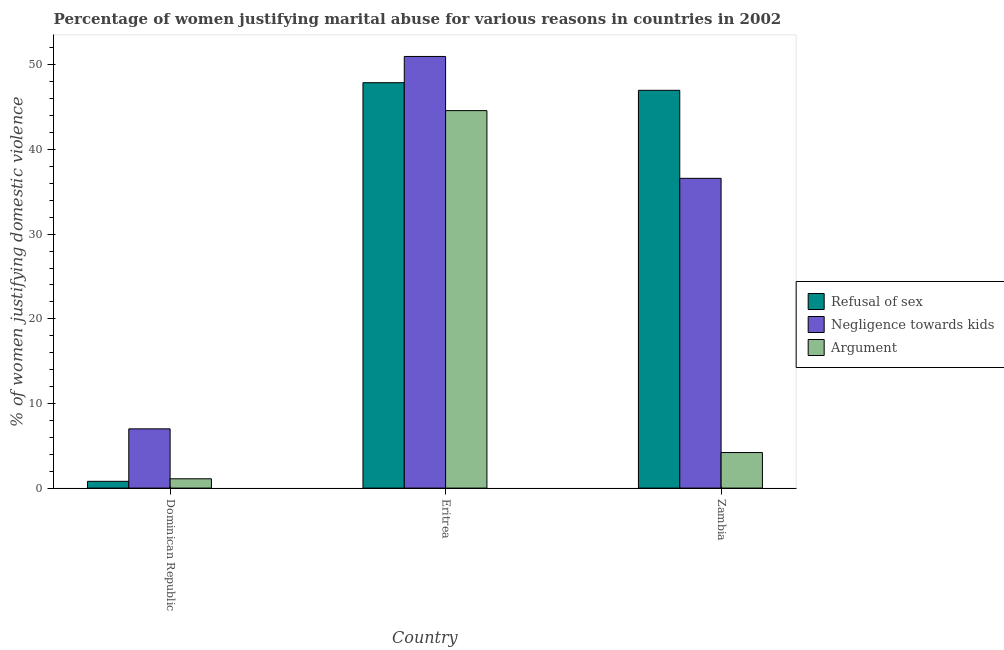How many different coloured bars are there?
Your answer should be compact. 3. Are the number of bars on each tick of the X-axis equal?
Keep it short and to the point. Yes. How many bars are there on the 3rd tick from the left?
Keep it short and to the point. 3. What is the label of the 1st group of bars from the left?
Offer a very short reply. Dominican Republic. What is the percentage of women justifying domestic violence due to negligence towards kids in Zambia?
Provide a succinct answer. 36.6. Across all countries, what is the minimum percentage of women justifying domestic violence due to negligence towards kids?
Your answer should be very brief. 7. In which country was the percentage of women justifying domestic violence due to arguments maximum?
Make the answer very short. Eritrea. In which country was the percentage of women justifying domestic violence due to negligence towards kids minimum?
Give a very brief answer. Dominican Republic. What is the total percentage of women justifying domestic violence due to arguments in the graph?
Ensure brevity in your answer.  49.9. What is the difference between the percentage of women justifying domestic violence due to negligence towards kids in Dominican Republic and that in Zambia?
Keep it short and to the point. -29.6. What is the difference between the percentage of women justifying domestic violence due to arguments in Dominican Republic and the percentage of women justifying domestic violence due to negligence towards kids in Eritrea?
Provide a succinct answer. -49.9. What is the average percentage of women justifying domestic violence due to negligence towards kids per country?
Ensure brevity in your answer.  31.53. In how many countries, is the percentage of women justifying domestic violence due to negligence towards kids greater than 4 %?
Your answer should be compact. 3. What is the ratio of the percentage of women justifying domestic violence due to negligence towards kids in Eritrea to that in Zambia?
Make the answer very short. 1.39. Is the percentage of women justifying domestic violence due to arguments in Eritrea less than that in Zambia?
Your answer should be compact. No. What is the difference between the highest and the second highest percentage of women justifying domestic violence due to refusal of sex?
Your response must be concise. 0.9. Is the sum of the percentage of women justifying domestic violence due to refusal of sex in Eritrea and Zambia greater than the maximum percentage of women justifying domestic violence due to arguments across all countries?
Offer a terse response. Yes. What does the 1st bar from the left in Zambia represents?
Offer a very short reply. Refusal of sex. What does the 2nd bar from the right in Zambia represents?
Keep it short and to the point. Negligence towards kids. How many countries are there in the graph?
Make the answer very short. 3. Does the graph contain grids?
Make the answer very short. No. Where does the legend appear in the graph?
Keep it short and to the point. Center right. How many legend labels are there?
Your answer should be compact. 3. What is the title of the graph?
Keep it short and to the point. Percentage of women justifying marital abuse for various reasons in countries in 2002. Does "Hydroelectric sources" appear as one of the legend labels in the graph?
Your answer should be compact. No. What is the label or title of the Y-axis?
Provide a succinct answer. % of women justifying domestic violence. What is the % of women justifying domestic violence of Refusal of sex in Dominican Republic?
Keep it short and to the point. 0.8. What is the % of women justifying domestic violence of Refusal of sex in Eritrea?
Offer a very short reply. 47.9. What is the % of women justifying domestic violence in Argument in Eritrea?
Offer a very short reply. 44.6. What is the % of women justifying domestic violence of Negligence towards kids in Zambia?
Offer a very short reply. 36.6. Across all countries, what is the maximum % of women justifying domestic violence of Refusal of sex?
Provide a short and direct response. 47.9. Across all countries, what is the maximum % of women justifying domestic violence in Argument?
Give a very brief answer. 44.6. Across all countries, what is the minimum % of women justifying domestic violence of Refusal of sex?
Provide a succinct answer. 0.8. Across all countries, what is the minimum % of women justifying domestic violence in Argument?
Your answer should be very brief. 1.1. What is the total % of women justifying domestic violence in Refusal of sex in the graph?
Your response must be concise. 95.7. What is the total % of women justifying domestic violence in Negligence towards kids in the graph?
Your answer should be very brief. 94.6. What is the total % of women justifying domestic violence of Argument in the graph?
Provide a succinct answer. 49.9. What is the difference between the % of women justifying domestic violence in Refusal of sex in Dominican Republic and that in Eritrea?
Provide a short and direct response. -47.1. What is the difference between the % of women justifying domestic violence in Negligence towards kids in Dominican Republic and that in Eritrea?
Offer a terse response. -44. What is the difference between the % of women justifying domestic violence in Argument in Dominican Republic and that in Eritrea?
Your answer should be very brief. -43.5. What is the difference between the % of women justifying domestic violence in Refusal of sex in Dominican Republic and that in Zambia?
Offer a very short reply. -46.2. What is the difference between the % of women justifying domestic violence of Negligence towards kids in Dominican Republic and that in Zambia?
Make the answer very short. -29.6. What is the difference between the % of women justifying domestic violence in Refusal of sex in Eritrea and that in Zambia?
Offer a very short reply. 0.9. What is the difference between the % of women justifying domestic violence in Argument in Eritrea and that in Zambia?
Provide a short and direct response. 40.4. What is the difference between the % of women justifying domestic violence in Refusal of sex in Dominican Republic and the % of women justifying domestic violence in Negligence towards kids in Eritrea?
Offer a terse response. -50.2. What is the difference between the % of women justifying domestic violence in Refusal of sex in Dominican Republic and the % of women justifying domestic violence in Argument in Eritrea?
Provide a succinct answer. -43.8. What is the difference between the % of women justifying domestic violence in Negligence towards kids in Dominican Republic and the % of women justifying domestic violence in Argument in Eritrea?
Give a very brief answer. -37.6. What is the difference between the % of women justifying domestic violence in Refusal of sex in Dominican Republic and the % of women justifying domestic violence in Negligence towards kids in Zambia?
Provide a succinct answer. -35.8. What is the difference between the % of women justifying domestic violence of Negligence towards kids in Dominican Republic and the % of women justifying domestic violence of Argument in Zambia?
Your response must be concise. 2.8. What is the difference between the % of women justifying domestic violence of Refusal of sex in Eritrea and the % of women justifying domestic violence of Argument in Zambia?
Offer a very short reply. 43.7. What is the difference between the % of women justifying domestic violence in Negligence towards kids in Eritrea and the % of women justifying domestic violence in Argument in Zambia?
Provide a short and direct response. 46.8. What is the average % of women justifying domestic violence of Refusal of sex per country?
Keep it short and to the point. 31.9. What is the average % of women justifying domestic violence in Negligence towards kids per country?
Offer a very short reply. 31.53. What is the average % of women justifying domestic violence of Argument per country?
Offer a very short reply. 16.63. What is the difference between the % of women justifying domestic violence of Refusal of sex and % of women justifying domestic violence of Argument in Dominican Republic?
Offer a terse response. -0.3. What is the difference between the % of women justifying domestic violence of Negligence towards kids and % of women justifying domestic violence of Argument in Dominican Republic?
Your response must be concise. 5.9. What is the difference between the % of women justifying domestic violence of Refusal of sex and % of women justifying domestic violence of Argument in Eritrea?
Ensure brevity in your answer.  3.3. What is the difference between the % of women justifying domestic violence in Refusal of sex and % of women justifying domestic violence in Argument in Zambia?
Offer a very short reply. 42.8. What is the difference between the % of women justifying domestic violence in Negligence towards kids and % of women justifying domestic violence in Argument in Zambia?
Offer a terse response. 32.4. What is the ratio of the % of women justifying domestic violence in Refusal of sex in Dominican Republic to that in Eritrea?
Your answer should be very brief. 0.02. What is the ratio of the % of women justifying domestic violence in Negligence towards kids in Dominican Republic to that in Eritrea?
Keep it short and to the point. 0.14. What is the ratio of the % of women justifying domestic violence of Argument in Dominican Republic to that in Eritrea?
Make the answer very short. 0.02. What is the ratio of the % of women justifying domestic violence in Refusal of sex in Dominican Republic to that in Zambia?
Provide a short and direct response. 0.02. What is the ratio of the % of women justifying domestic violence of Negligence towards kids in Dominican Republic to that in Zambia?
Your response must be concise. 0.19. What is the ratio of the % of women justifying domestic violence of Argument in Dominican Republic to that in Zambia?
Provide a short and direct response. 0.26. What is the ratio of the % of women justifying domestic violence of Refusal of sex in Eritrea to that in Zambia?
Your response must be concise. 1.02. What is the ratio of the % of women justifying domestic violence in Negligence towards kids in Eritrea to that in Zambia?
Offer a very short reply. 1.39. What is the ratio of the % of women justifying domestic violence of Argument in Eritrea to that in Zambia?
Your answer should be very brief. 10.62. What is the difference between the highest and the second highest % of women justifying domestic violence of Negligence towards kids?
Make the answer very short. 14.4. What is the difference between the highest and the second highest % of women justifying domestic violence of Argument?
Keep it short and to the point. 40.4. What is the difference between the highest and the lowest % of women justifying domestic violence of Refusal of sex?
Offer a very short reply. 47.1. What is the difference between the highest and the lowest % of women justifying domestic violence in Argument?
Offer a terse response. 43.5. 